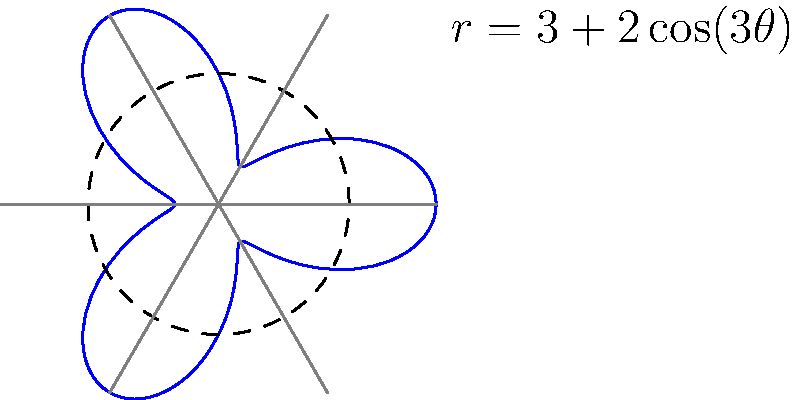A marine protected area is being mapped using polar coordinates. The boundary of the area is described by the equation $r = 3 + 2\cos(3\theta)$ (in kilometers). Calculate the total area of this protected marine ecosystem to the nearest square kilometer. To calculate the area of the region described by the polar equation $r = 3 + 2\cos(3\theta)$, we'll use the formula for area in polar coordinates:

$$A = \frac{1}{2}\int_{0}^{2\pi} r^2 d\theta$$

Step 1: Substitute the given equation into the area formula:
$$A = \frac{1}{2}\int_{0}^{2\pi} (3 + 2\cos(3\theta))^2 d\theta$$

Step 2: Expand the integrand:
$$(3 + 2\cos(3\theta))^2 = 9 + 12\cos(3\theta) + 4\cos^2(3\theta)$$

Step 3: Substitute this back into the integral:
$$A = \frac{1}{2}\int_{0}^{2\pi} (9 + 12\cos(3\theta) + 4\cos^2(3\theta)) d\theta$$

Step 4: Integrate each term:
- $\int_{0}^{2\pi} 9 d\theta = 9\theta |_{0}^{2\pi} = 18\pi$
- $\int_{0}^{2\pi} 12\cos(3\theta) d\theta = 4\sin(3\theta) |_{0}^{2\pi} = 0$
- $\int_{0}^{2\pi} 4\cos^2(3\theta) d\theta = 2\theta + \frac{2}{3}\sin(6\theta) |_{0}^{2\pi} = 4\pi$

Step 5: Sum up the results:
$$A = \frac{1}{2}(18\pi + 0 + 4\pi) = 11\pi$$

Step 6: Convert to square kilometers (rounded to the nearest whole number):
$$A \approx 35 \text{ km}^2$$
Answer: 35 km² 